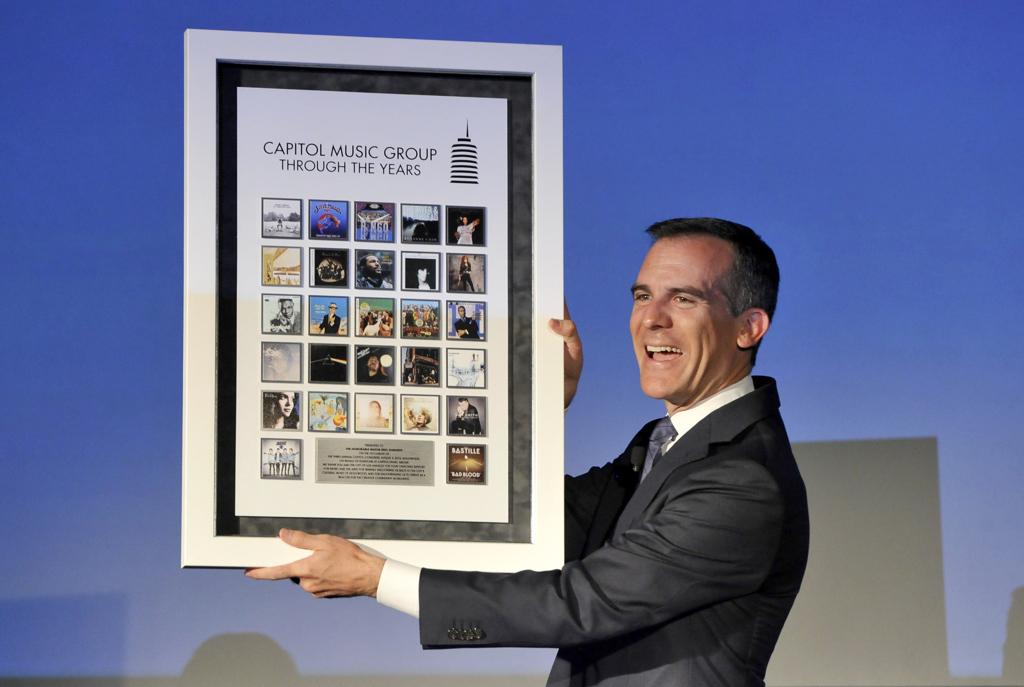What music company is featured here?
Ensure brevity in your answer.  Capitol music group. What group is this poster about?
Provide a short and direct response. Capitol music group. 